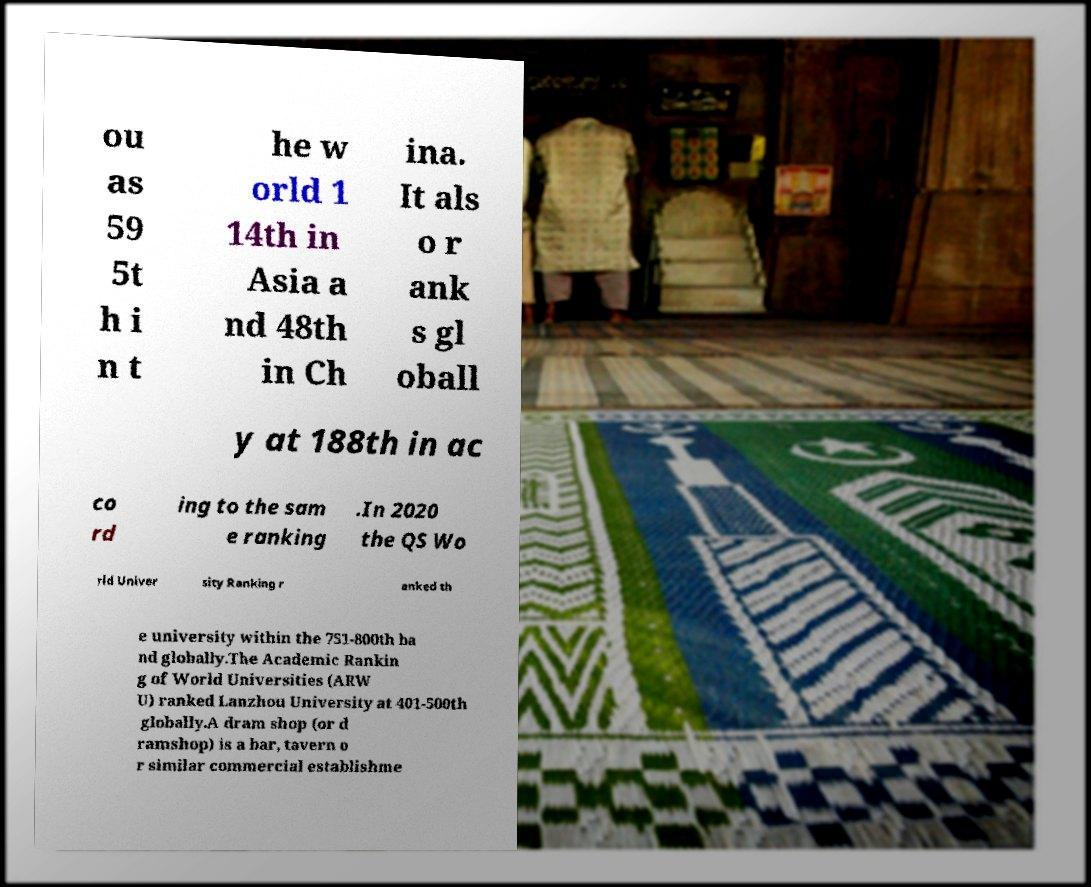Please identify and transcribe the text found in this image. ou as 59 5t h i n t he w orld 1 14th in Asia a nd 48th in Ch ina. It als o r ank s gl oball y at 188th in ac co rd ing to the sam e ranking .In 2020 the QS Wo rld Univer sity Ranking r anked th e university within the 751-800th ba nd globally.The Academic Rankin g of World Universities (ARW U) ranked Lanzhou University at 401-500th globally.A dram shop (or d ramshop) is a bar, tavern o r similar commercial establishme 